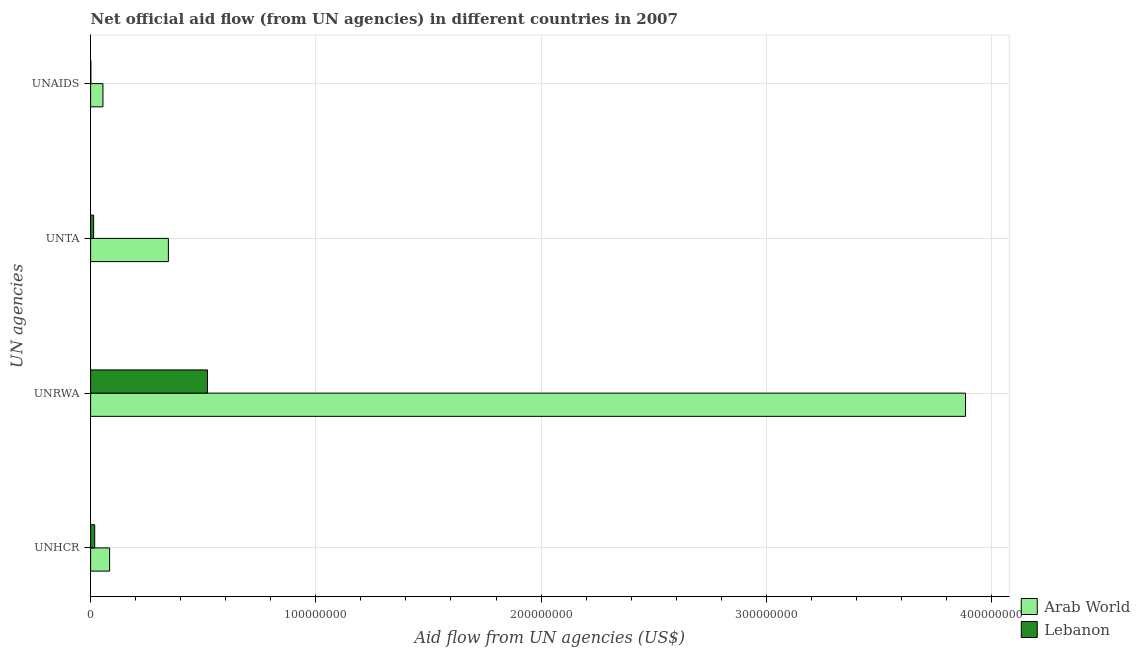How many different coloured bars are there?
Keep it short and to the point. 2. Are the number of bars per tick equal to the number of legend labels?
Give a very brief answer. Yes. What is the label of the 1st group of bars from the top?
Ensure brevity in your answer.  UNAIDS. What is the amount of aid given by unhcr in Arab World?
Ensure brevity in your answer.  8.44e+06. Across all countries, what is the maximum amount of aid given by unrwa?
Offer a very short reply. 3.88e+08. Across all countries, what is the minimum amount of aid given by unhcr?
Provide a short and direct response. 1.82e+06. In which country was the amount of aid given by unhcr maximum?
Your answer should be compact. Arab World. In which country was the amount of aid given by unta minimum?
Your answer should be very brief. Lebanon. What is the total amount of aid given by unaids in the graph?
Give a very brief answer. 5.61e+06. What is the difference between the amount of aid given by unhcr in Arab World and that in Lebanon?
Give a very brief answer. 6.62e+06. What is the difference between the amount of aid given by unaids in Arab World and the amount of aid given by unhcr in Lebanon?
Offer a terse response. 3.67e+06. What is the average amount of aid given by unaids per country?
Offer a very short reply. 2.80e+06. What is the difference between the amount of aid given by unhcr and amount of aid given by unaids in Arab World?
Your response must be concise. 2.95e+06. In how many countries, is the amount of aid given by unta greater than 260000000 US$?
Give a very brief answer. 0. What is the ratio of the amount of aid given by unta in Lebanon to that in Arab World?
Your answer should be very brief. 0.04. Is the amount of aid given by unrwa in Arab World less than that in Lebanon?
Keep it short and to the point. No. What is the difference between the highest and the second highest amount of aid given by unta?
Your answer should be compact. 3.32e+07. What is the difference between the highest and the lowest amount of aid given by unaids?
Make the answer very short. 5.37e+06. What does the 2nd bar from the top in UNHCR represents?
Ensure brevity in your answer.  Arab World. What does the 2nd bar from the bottom in UNTA represents?
Provide a succinct answer. Lebanon. How many countries are there in the graph?
Your response must be concise. 2. Where does the legend appear in the graph?
Your answer should be very brief. Bottom right. How are the legend labels stacked?
Your answer should be very brief. Vertical. What is the title of the graph?
Offer a terse response. Net official aid flow (from UN agencies) in different countries in 2007. What is the label or title of the X-axis?
Your answer should be very brief. Aid flow from UN agencies (US$). What is the label or title of the Y-axis?
Give a very brief answer. UN agencies. What is the Aid flow from UN agencies (US$) in Arab World in UNHCR?
Give a very brief answer. 8.44e+06. What is the Aid flow from UN agencies (US$) in Lebanon in UNHCR?
Offer a terse response. 1.82e+06. What is the Aid flow from UN agencies (US$) of Arab World in UNRWA?
Make the answer very short. 3.88e+08. What is the Aid flow from UN agencies (US$) of Lebanon in UNRWA?
Your answer should be compact. 5.19e+07. What is the Aid flow from UN agencies (US$) of Arab World in UNTA?
Your answer should be compact. 3.45e+07. What is the Aid flow from UN agencies (US$) of Lebanon in UNTA?
Make the answer very short. 1.34e+06. What is the Aid flow from UN agencies (US$) in Arab World in UNAIDS?
Your response must be concise. 5.49e+06. Across all UN agencies, what is the maximum Aid flow from UN agencies (US$) of Arab World?
Give a very brief answer. 3.88e+08. Across all UN agencies, what is the maximum Aid flow from UN agencies (US$) in Lebanon?
Keep it short and to the point. 5.19e+07. Across all UN agencies, what is the minimum Aid flow from UN agencies (US$) in Arab World?
Ensure brevity in your answer.  5.49e+06. Across all UN agencies, what is the minimum Aid flow from UN agencies (US$) of Lebanon?
Your answer should be compact. 1.20e+05. What is the total Aid flow from UN agencies (US$) of Arab World in the graph?
Provide a succinct answer. 4.37e+08. What is the total Aid flow from UN agencies (US$) in Lebanon in the graph?
Your answer should be very brief. 5.52e+07. What is the difference between the Aid flow from UN agencies (US$) of Arab World in UNHCR and that in UNRWA?
Offer a very short reply. -3.80e+08. What is the difference between the Aid flow from UN agencies (US$) in Lebanon in UNHCR and that in UNRWA?
Offer a terse response. -5.01e+07. What is the difference between the Aid flow from UN agencies (US$) of Arab World in UNHCR and that in UNTA?
Your response must be concise. -2.61e+07. What is the difference between the Aid flow from UN agencies (US$) of Lebanon in UNHCR and that in UNTA?
Your response must be concise. 4.80e+05. What is the difference between the Aid flow from UN agencies (US$) of Arab World in UNHCR and that in UNAIDS?
Make the answer very short. 2.95e+06. What is the difference between the Aid flow from UN agencies (US$) of Lebanon in UNHCR and that in UNAIDS?
Your answer should be compact. 1.70e+06. What is the difference between the Aid flow from UN agencies (US$) of Arab World in UNRWA and that in UNTA?
Give a very brief answer. 3.54e+08. What is the difference between the Aid flow from UN agencies (US$) of Lebanon in UNRWA and that in UNTA?
Keep it short and to the point. 5.06e+07. What is the difference between the Aid flow from UN agencies (US$) of Arab World in UNRWA and that in UNAIDS?
Give a very brief answer. 3.83e+08. What is the difference between the Aid flow from UN agencies (US$) of Lebanon in UNRWA and that in UNAIDS?
Your answer should be very brief. 5.18e+07. What is the difference between the Aid flow from UN agencies (US$) of Arab World in UNTA and that in UNAIDS?
Provide a short and direct response. 2.90e+07. What is the difference between the Aid flow from UN agencies (US$) in Lebanon in UNTA and that in UNAIDS?
Provide a short and direct response. 1.22e+06. What is the difference between the Aid flow from UN agencies (US$) in Arab World in UNHCR and the Aid flow from UN agencies (US$) in Lebanon in UNRWA?
Ensure brevity in your answer.  -4.34e+07. What is the difference between the Aid flow from UN agencies (US$) of Arab World in UNHCR and the Aid flow from UN agencies (US$) of Lebanon in UNTA?
Your answer should be very brief. 7.10e+06. What is the difference between the Aid flow from UN agencies (US$) in Arab World in UNHCR and the Aid flow from UN agencies (US$) in Lebanon in UNAIDS?
Your response must be concise. 8.32e+06. What is the difference between the Aid flow from UN agencies (US$) in Arab World in UNRWA and the Aid flow from UN agencies (US$) in Lebanon in UNTA?
Your answer should be very brief. 3.87e+08. What is the difference between the Aid flow from UN agencies (US$) in Arab World in UNRWA and the Aid flow from UN agencies (US$) in Lebanon in UNAIDS?
Make the answer very short. 3.88e+08. What is the difference between the Aid flow from UN agencies (US$) of Arab World in UNTA and the Aid flow from UN agencies (US$) of Lebanon in UNAIDS?
Ensure brevity in your answer.  3.44e+07. What is the average Aid flow from UN agencies (US$) of Arab World per UN agencies?
Your answer should be very brief. 1.09e+08. What is the average Aid flow from UN agencies (US$) in Lebanon per UN agencies?
Make the answer very short. 1.38e+07. What is the difference between the Aid flow from UN agencies (US$) in Arab World and Aid flow from UN agencies (US$) in Lebanon in UNHCR?
Keep it short and to the point. 6.62e+06. What is the difference between the Aid flow from UN agencies (US$) of Arab World and Aid flow from UN agencies (US$) of Lebanon in UNRWA?
Offer a terse response. 3.37e+08. What is the difference between the Aid flow from UN agencies (US$) of Arab World and Aid flow from UN agencies (US$) of Lebanon in UNTA?
Your answer should be compact. 3.32e+07. What is the difference between the Aid flow from UN agencies (US$) of Arab World and Aid flow from UN agencies (US$) of Lebanon in UNAIDS?
Offer a very short reply. 5.37e+06. What is the ratio of the Aid flow from UN agencies (US$) in Arab World in UNHCR to that in UNRWA?
Provide a short and direct response. 0.02. What is the ratio of the Aid flow from UN agencies (US$) of Lebanon in UNHCR to that in UNRWA?
Provide a short and direct response. 0.04. What is the ratio of the Aid flow from UN agencies (US$) of Arab World in UNHCR to that in UNTA?
Offer a terse response. 0.24. What is the ratio of the Aid flow from UN agencies (US$) of Lebanon in UNHCR to that in UNTA?
Offer a very short reply. 1.36. What is the ratio of the Aid flow from UN agencies (US$) in Arab World in UNHCR to that in UNAIDS?
Your response must be concise. 1.54. What is the ratio of the Aid flow from UN agencies (US$) of Lebanon in UNHCR to that in UNAIDS?
Ensure brevity in your answer.  15.17. What is the ratio of the Aid flow from UN agencies (US$) in Arab World in UNRWA to that in UNTA?
Provide a short and direct response. 11.25. What is the ratio of the Aid flow from UN agencies (US$) in Lebanon in UNRWA to that in UNTA?
Offer a very short reply. 38.72. What is the ratio of the Aid flow from UN agencies (US$) in Arab World in UNRWA to that in UNAIDS?
Provide a succinct answer. 70.75. What is the ratio of the Aid flow from UN agencies (US$) of Lebanon in UNRWA to that in UNAIDS?
Offer a terse response. 432.42. What is the ratio of the Aid flow from UN agencies (US$) of Arab World in UNTA to that in UNAIDS?
Make the answer very short. 6.29. What is the ratio of the Aid flow from UN agencies (US$) of Lebanon in UNTA to that in UNAIDS?
Give a very brief answer. 11.17. What is the difference between the highest and the second highest Aid flow from UN agencies (US$) of Arab World?
Keep it short and to the point. 3.54e+08. What is the difference between the highest and the second highest Aid flow from UN agencies (US$) in Lebanon?
Your answer should be very brief. 5.01e+07. What is the difference between the highest and the lowest Aid flow from UN agencies (US$) in Arab World?
Ensure brevity in your answer.  3.83e+08. What is the difference between the highest and the lowest Aid flow from UN agencies (US$) of Lebanon?
Keep it short and to the point. 5.18e+07. 